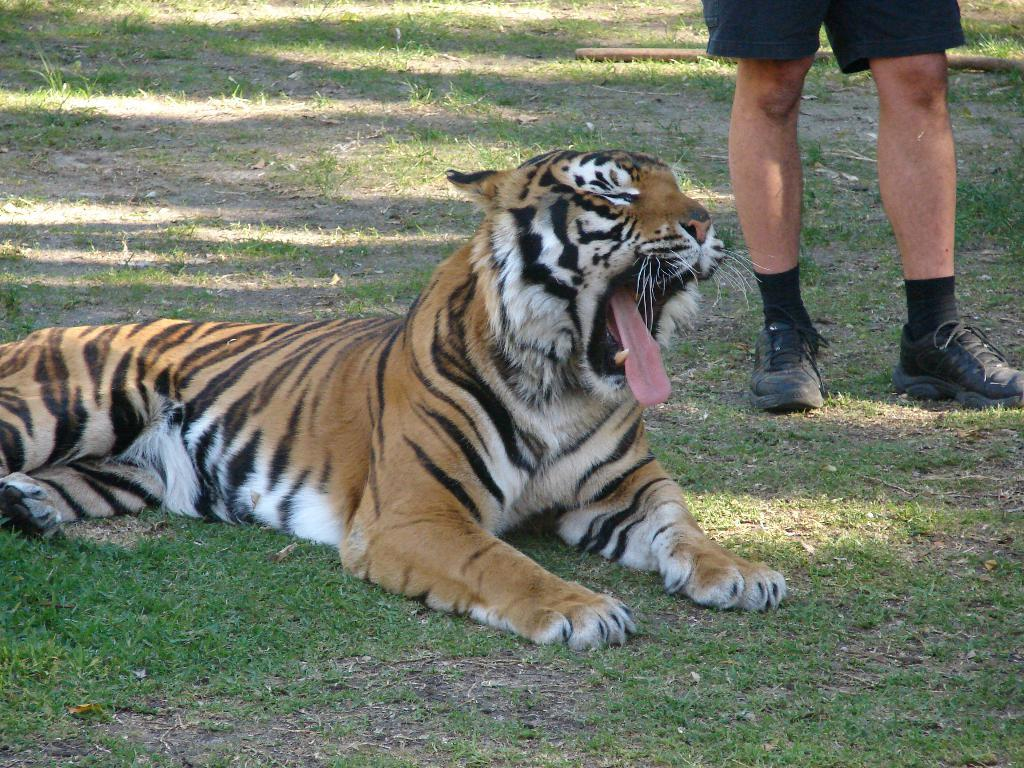What animal is sitting on the grass in the image? There is a tiger sitting on the grass in the image. What is the person in the image doing? The person is standing in the image. What type of terrain is visible at the bottom of the image? Grass and mud are visible at the bottom of the image. What object can be seen on the grass in the background of the image? There is a stick on the grass in the background of the image. What type of coat is the tiger wearing in the image? Tigers do not wear coats, so this question is not applicable to the image. 